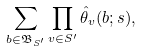<formula> <loc_0><loc_0><loc_500><loc_500>\sum _ { b \in \mathfrak B _ { S ^ { \prime } } } \prod _ { v \in S ^ { \prime } } \hat { \theta } _ { v } ( b ; s ) ,</formula> 